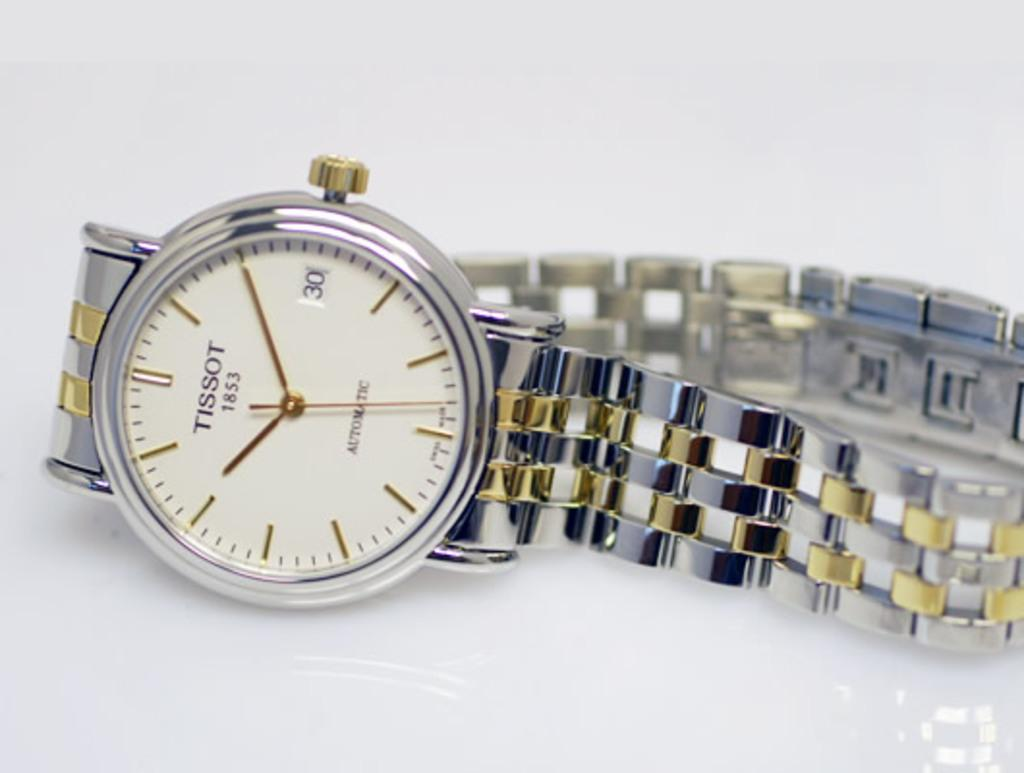<image>
Give a short and clear explanation of the subsequent image. Tissor silver and gold watch sits on a table 